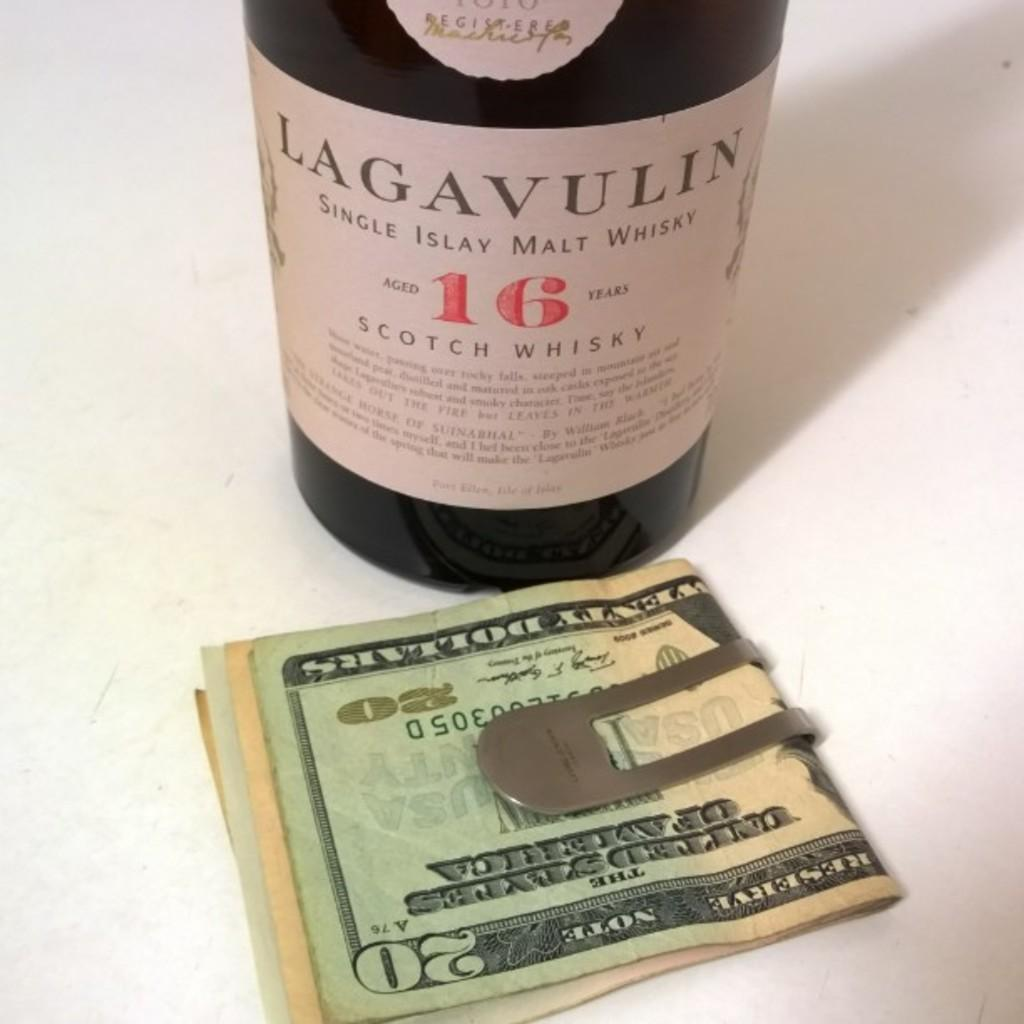<image>
Give a short and clear explanation of the subsequent image. Bottle with a label that says "Lagavulin" in front of a 20 dollar bill. 